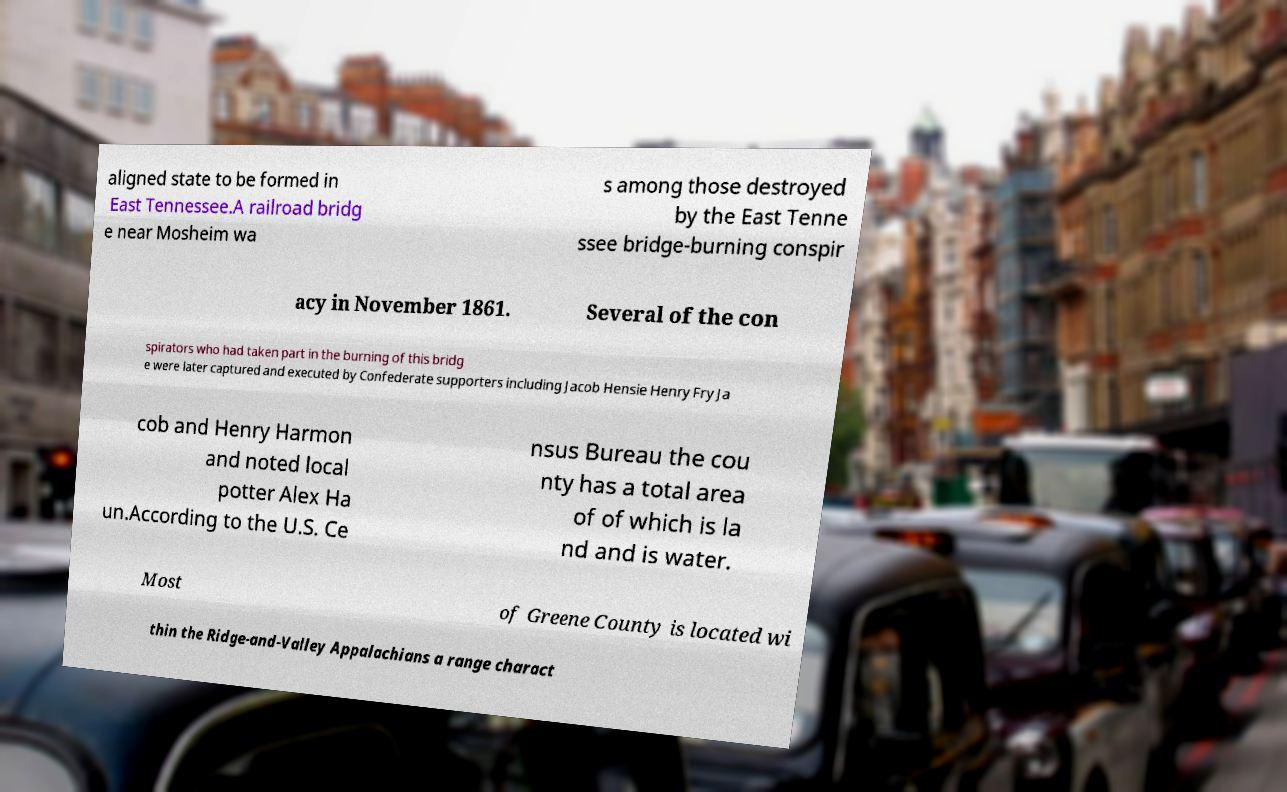Can you read and provide the text displayed in the image?This photo seems to have some interesting text. Can you extract and type it out for me? aligned state to be formed in East Tennessee.A railroad bridg e near Mosheim wa s among those destroyed by the East Tenne ssee bridge-burning conspir acy in November 1861. Several of the con spirators who had taken part in the burning of this bridg e were later captured and executed by Confederate supporters including Jacob Hensie Henry Fry Ja cob and Henry Harmon and noted local potter Alex Ha un.According to the U.S. Ce nsus Bureau the cou nty has a total area of of which is la nd and is water. Most of Greene County is located wi thin the Ridge-and-Valley Appalachians a range charact 